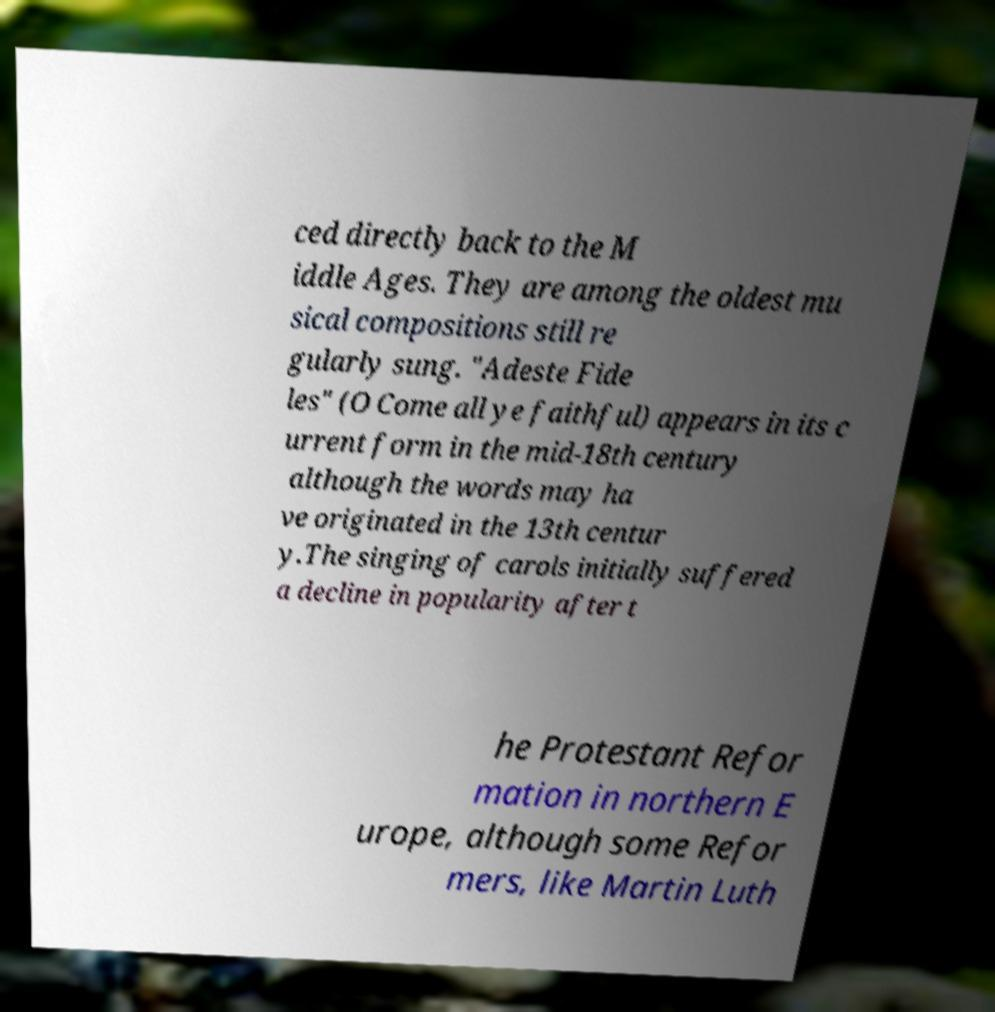Can you accurately transcribe the text from the provided image for me? ced directly back to the M iddle Ages. They are among the oldest mu sical compositions still re gularly sung. "Adeste Fide les" (O Come all ye faithful) appears in its c urrent form in the mid-18th century although the words may ha ve originated in the 13th centur y.The singing of carols initially suffered a decline in popularity after t he Protestant Refor mation in northern E urope, although some Refor mers, like Martin Luth 